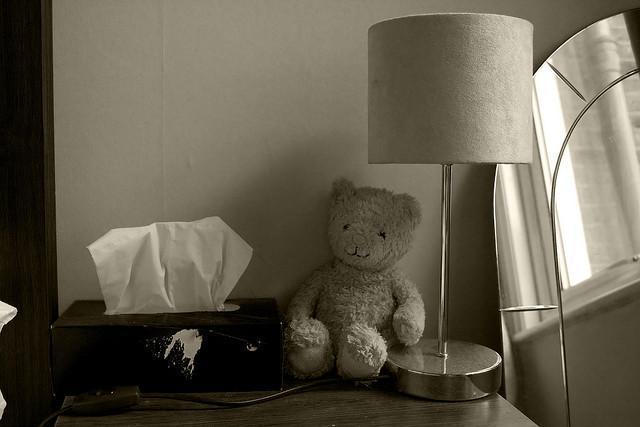How many people are there?
Give a very brief answer. 0. 